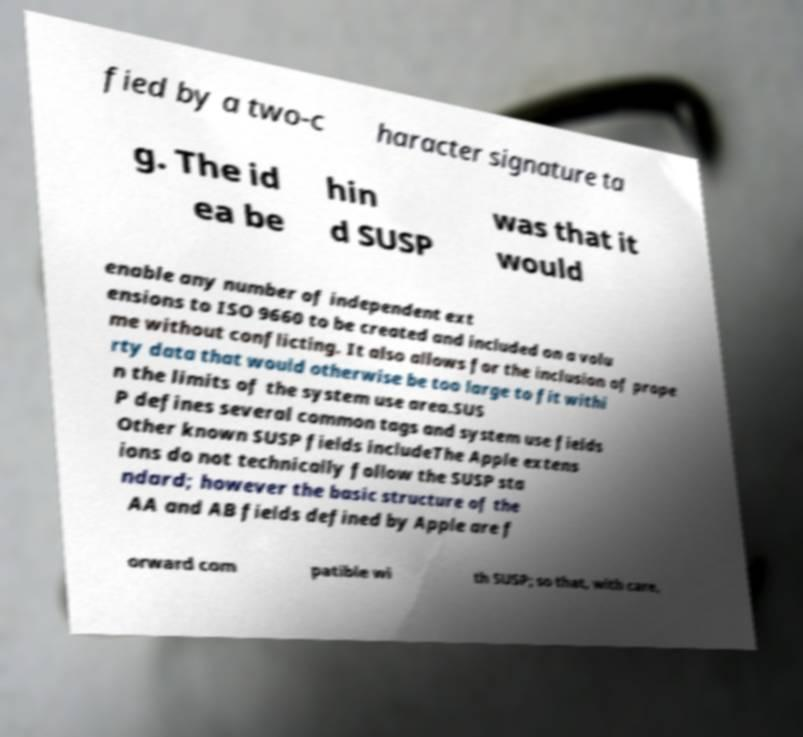Can you read and provide the text displayed in the image?This photo seems to have some interesting text. Can you extract and type it out for me? fied by a two-c haracter signature ta g. The id ea be hin d SUSP was that it would enable any number of independent ext ensions to ISO 9660 to be created and included on a volu me without conflicting. It also allows for the inclusion of prope rty data that would otherwise be too large to fit withi n the limits of the system use area.SUS P defines several common tags and system use fields Other known SUSP fields includeThe Apple extens ions do not technically follow the SUSP sta ndard; however the basic structure of the AA and AB fields defined by Apple are f orward com patible wi th SUSP; so that, with care, 